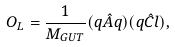<formula> <loc_0><loc_0><loc_500><loc_500>O _ { L } = \frac { 1 } { M _ { G U T } } ( q \hat { A } q ) ( q \hat { C } l ) ,</formula> 